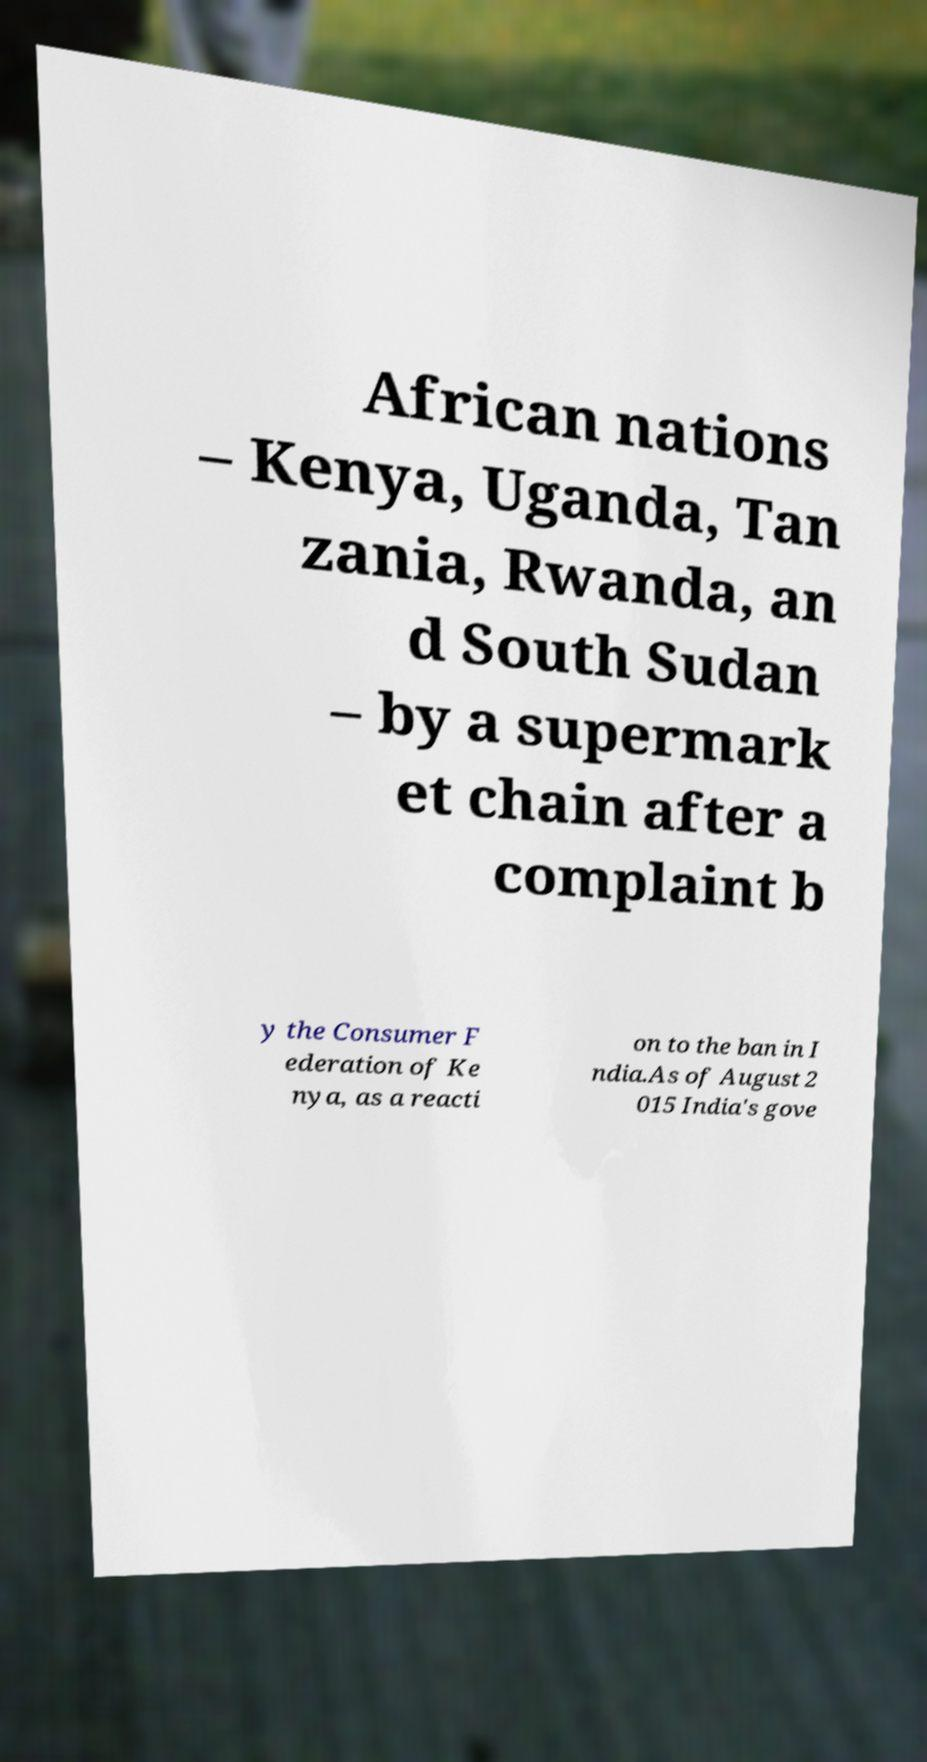For documentation purposes, I need the text within this image transcribed. Could you provide that? African nations – Kenya, Uganda, Tan zania, Rwanda, an d South Sudan – by a supermark et chain after a complaint b y the Consumer F ederation of Ke nya, as a reacti on to the ban in I ndia.As of August 2 015 India's gove 